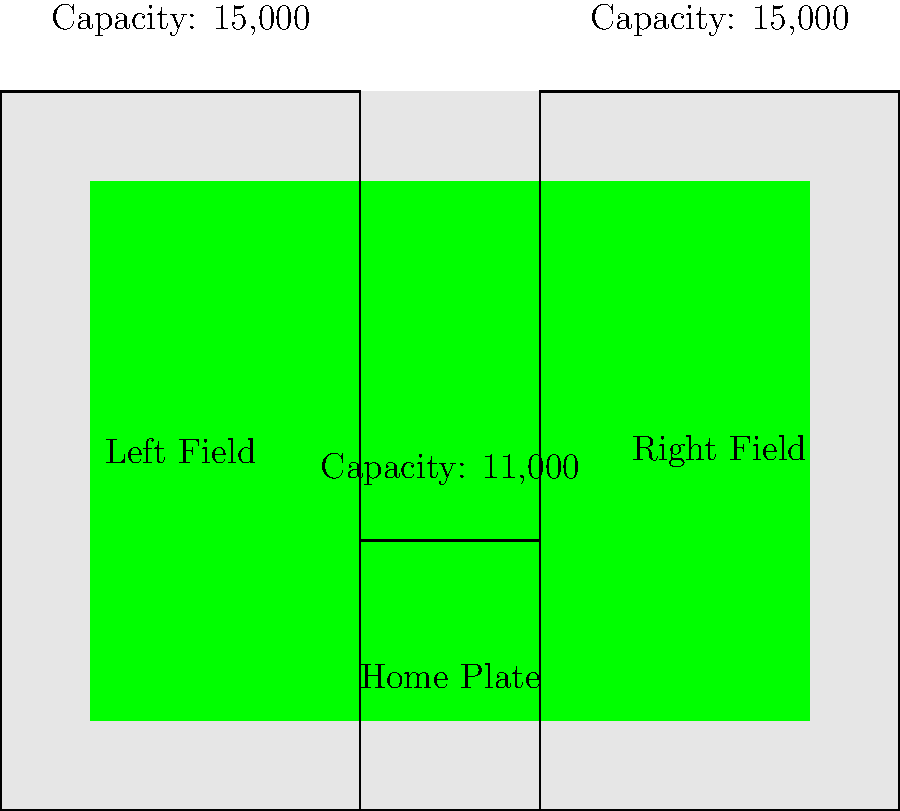As a longtime Cubs fan, you're familiar with Wrigley Field's unique layout. Based on the stadium diagram, if the Cubs decide to expand seating capacity by adding 5,000 seats equally distributed between the Left Field and Right Field sections, what would be the new total seating capacity of Wrigley Field? To solve this problem, let's follow these steps:

1. Identify the current seating capacity for each section:
   - Left Field: 15,000
   - Right Field: 15,000
   - Home Plate: 11,000

2. Calculate the current total seating capacity:
   $15,000 + 15,000 + 11,000 = 41,000$

3. Determine the number of new seats for each expanded section:
   5,000 seats ÷ 2 sections = 2,500 seats per section

4. Calculate the new capacity for Left Field and Right Field:
   - Left Field: $15,000 + 2,500 = 17,500$
   - Right Field: $15,000 + 2,500 = 17,500$

5. Calculate the new total seating capacity:
   $17,500 + 17,500 + 11,000 = 46,000$

Therefore, the new total seating capacity of Wrigley Field after the expansion would be 46,000.
Answer: 46,000 